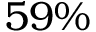<formula> <loc_0><loc_0><loc_500><loc_500>5 9 \%</formula> 